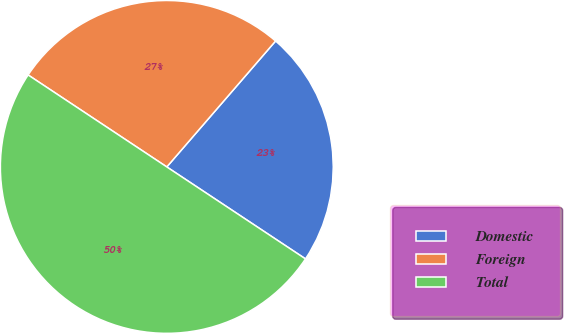<chart> <loc_0><loc_0><loc_500><loc_500><pie_chart><fcel>Domestic<fcel>Foreign<fcel>Total<nl><fcel>22.98%<fcel>27.02%<fcel>50.0%<nl></chart> 